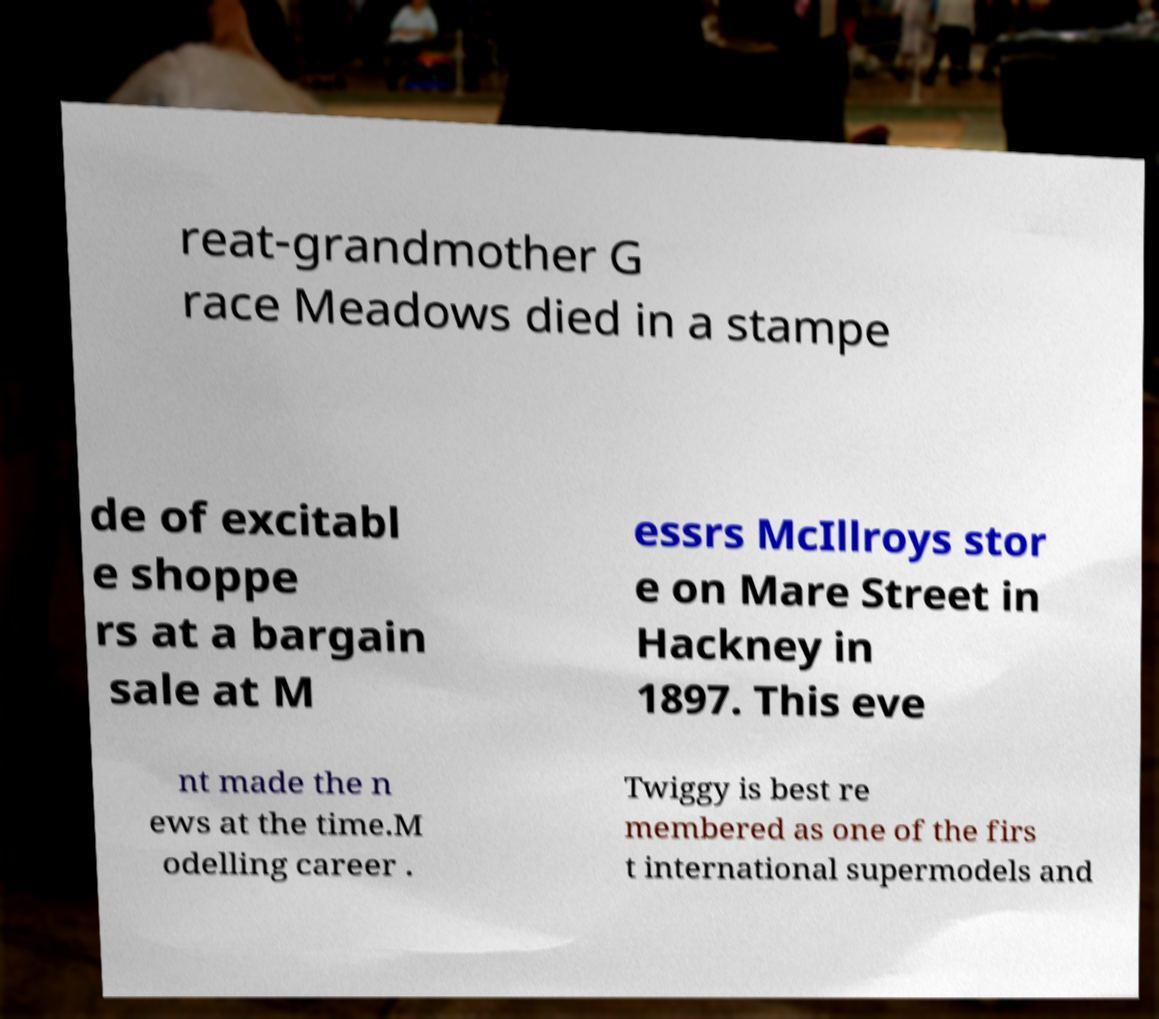Could you assist in decoding the text presented in this image and type it out clearly? reat-grandmother G race Meadows died in a stampe de of excitabl e shoppe rs at a bargain sale at M essrs McIllroys stor e on Mare Street in Hackney in 1897. This eve nt made the n ews at the time.M odelling career . Twiggy is best re membered as one of the firs t international supermodels and 